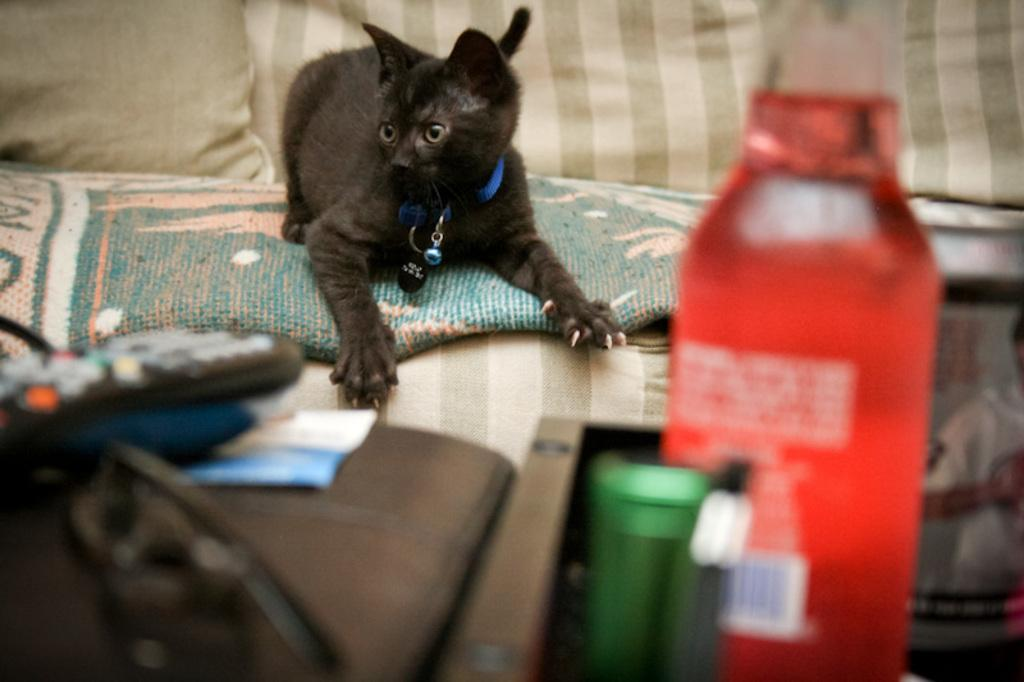What type of animal is in the image? There is a black cat in the image. What objects can be seen in the image besides the cat? There is a bottle and a remote in the image. Where is the cat located in the image? The cat is sitting on a bed. What type of health advice can be seen in the image? There is no health advice present in the image; it features a black cat, a bottle, and a remote. Is there a ring visible on the cat's paw in the image? There is no ring visible on the cat's paw in the image. 